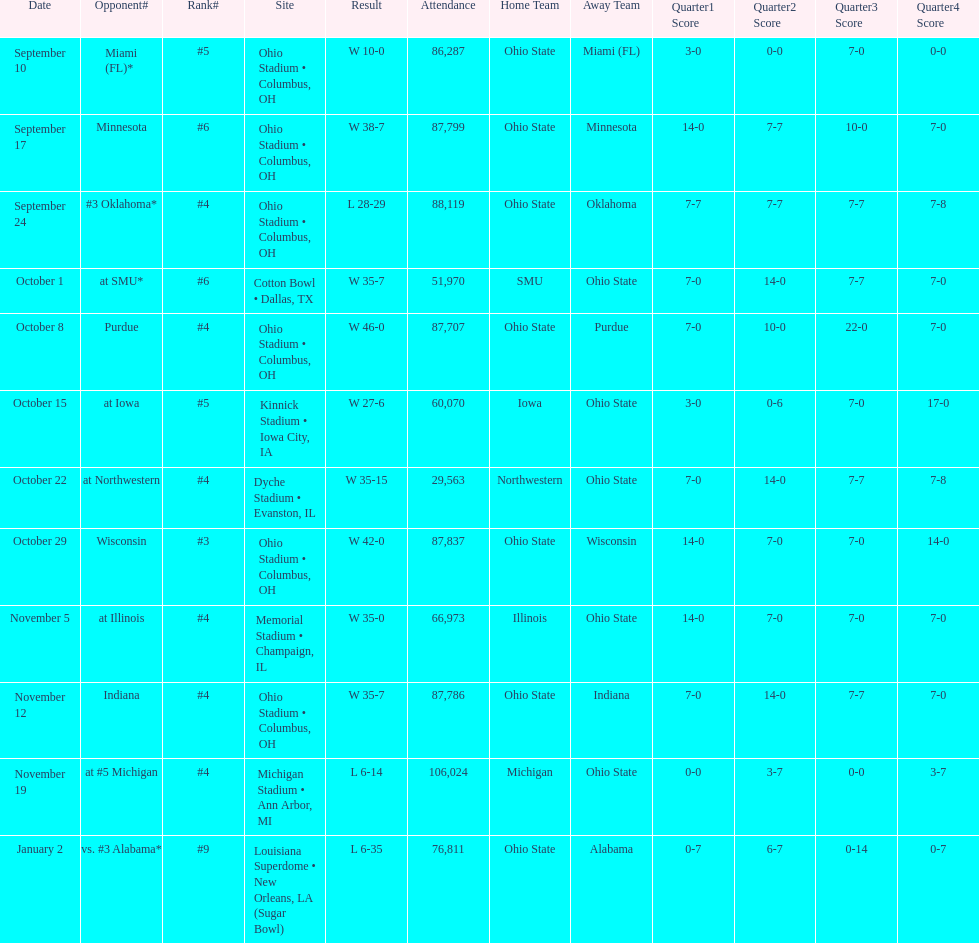On which date did the highest number of people attend? November 19. Could you parse the entire table? {'header': ['Date', 'Opponent#', 'Rank#', 'Site', 'Result', 'Attendance', 'Home Team', 'Away Team', 'Quarter1 Score', 'Quarter2 Score', 'Quarter3 Score', 'Quarter4 Score'], 'rows': [['September 10', 'Miami (FL)*', '#5', 'Ohio Stadium • Columbus, OH', 'W\xa010-0', '86,287', 'Ohio State', 'Miami (FL)', '3-0', '0-0', '7-0', '0-0'], ['September 17', 'Minnesota', '#6', 'Ohio Stadium • Columbus, OH', 'W\xa038-7', '87,799', 'Ohio State', 'Minnesota', '14-0', '7-7', '10-0', '7-0'], ['September 24', '#3\xa0Oklahoma*', '#4', 'Ohio Stadium • Columbus, OH', 'L\xa028-29', '88,119', 'Ohio State', 'Oklahoma', '7-7', '7-7', '7-7', '7-8'], ['October 1', 'at\xa0SMU*', '#6', 'Cotton Bowl • Dallas, TX', 'W\xa035-7', '51,970', 'SMU', 'Ohio State', '7-0', '14-0', '7-7', '7-0'], ['October 8', 'Purdue', '#4', 'Ohio Stadium • Columbus, OH', 'W\xa046-0', '87,707', 'Ohio State', 'Purdue', '7-0', '10-0', '22-0', '7-0'], ['October 15', 'at\xa0Iowa', '#5', 'Kinnick Stadium • Iowa City, IA', 'W\xa027-6', '60,070', 'Iowa', 'Ohio State', '3-0', '0-6', '7-0', '17-0'], ['October 22', 'at\xa0Northwestern', '#4', 'Dyche Stadium • Evanston, IL', 'W\xa035-15', '29,563', 'Northwestern', 'Ohio State', '7-0', '14-0', '7-7', '7-8'], ['October 29', 'Wisconsin', '#3', 'Ohio Stadium • Columbus, OH', 'W\xa042-0', '87,837', 'Ohio State', 'Wisconsin', '14-0', '7-0', '7-0', '14-0'], ['November 5', 'at\xa0Illinois', '#4', 'Memorial Stadium • Champaign, IL', 'W\xa035-0', '66,973', 'Illinois', 'Ohio State', '14-0', '7-0', '7-0', '7-0'], ['November 12', 'Indiana', '#4', 'Ohio Stadium • Columbus, OH', 'W\xa035-7', '87,786', 'Ohio State', 'Indiana', '7-0', '14-0', '7-7', '7-0'], ['November 19', 'at\xa0#5\xa0Michigan', '#4', 'Michigan Stadium • Ann Arbor, MI', 'L\xa06-14', '106,024', 'Michigan', 'Ohio State', '0-0', '3-7', '0-0', '3-7'], ['January 2', 'vs.\xa0#3\xa0Alabama*', '#9', 'Louisiana Superdome • New Orleans, LA (Sugar Bowl)', 'L\xa06-35', '76,811', 'Ohio State', 'Alabama', '0-7', '6-7', '0-14', '0-7']]} 